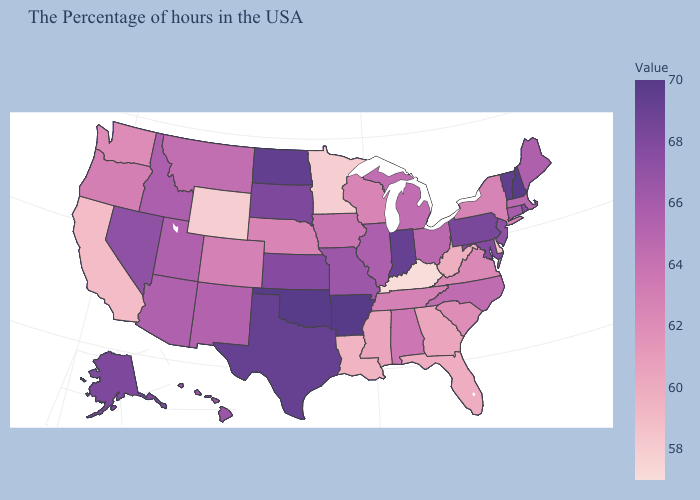Does the map have missing data?
Be succinct. No. Does Arkansas have the highest value in the USA?
Concise answer only. Yes. Which states have the lowest value in the South?
Answer briefly. Kentucky. Among the states that border Wyoming , does Nebraska have the highest value?
Quick response, please. No. Which states have the highest value in the USA?
Be succinct. Arkansas. Which states have the highest value in the USA?
Be succinct. Arkansas. 